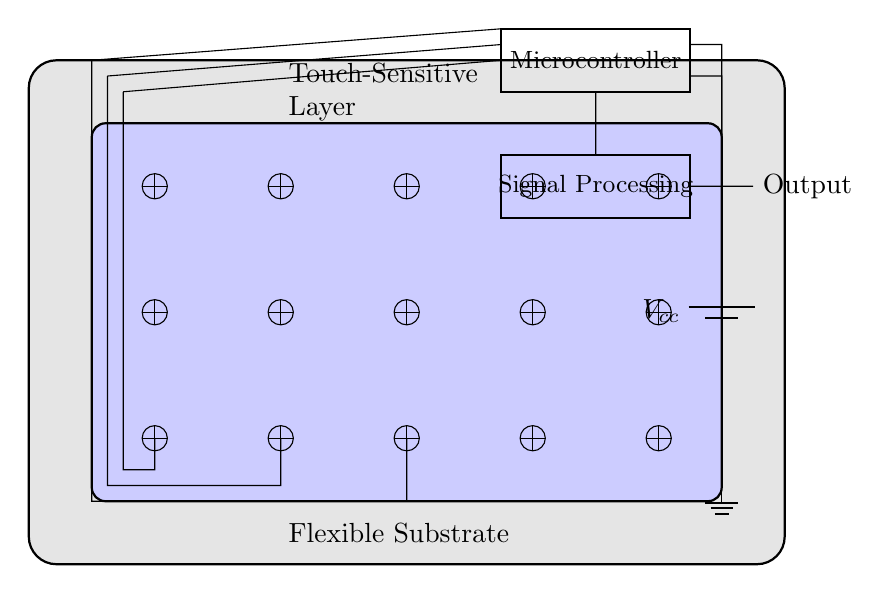What is the main application of this circuit? The circuit is designed for touch-sensitive applications, allowing interaction through a flexible interface.
Answer: Touch-sensitive interface How many capacitive sensors are in the circuit? There are a total of fifteen capacitive sensors arranged in a grid pattern within the touch-sensitive layer.
Answer: Fifteen What is the purpose of the microcontroller in this circuit? The microcontroller is used to process the signals received from the capacitive sensors and to control the output.
Answer: Signal processing What is the voltage supplied to this circuit? The circuit is powered by a battery supplying a voltage denoted as Vcc.
Answer: Vcc Why is the flexible substrate important in this circuit? The flexible substrate allows the touch-sensitive circuit to conform to different shapes and surfaces, enhancing usability in mobile devices.
Answer: Flexibility What type of processing is performed in the signal processing block? The signal processing block handles the interpretation of touch input and can filter and analyze the signals for various applications.
Answer: Signal interpretation What connects the microcontroller to the power supply? The connections consist of short wires linking the microcontroller’s outputs to the voltage source and ground for operation.
Answer: Wires 